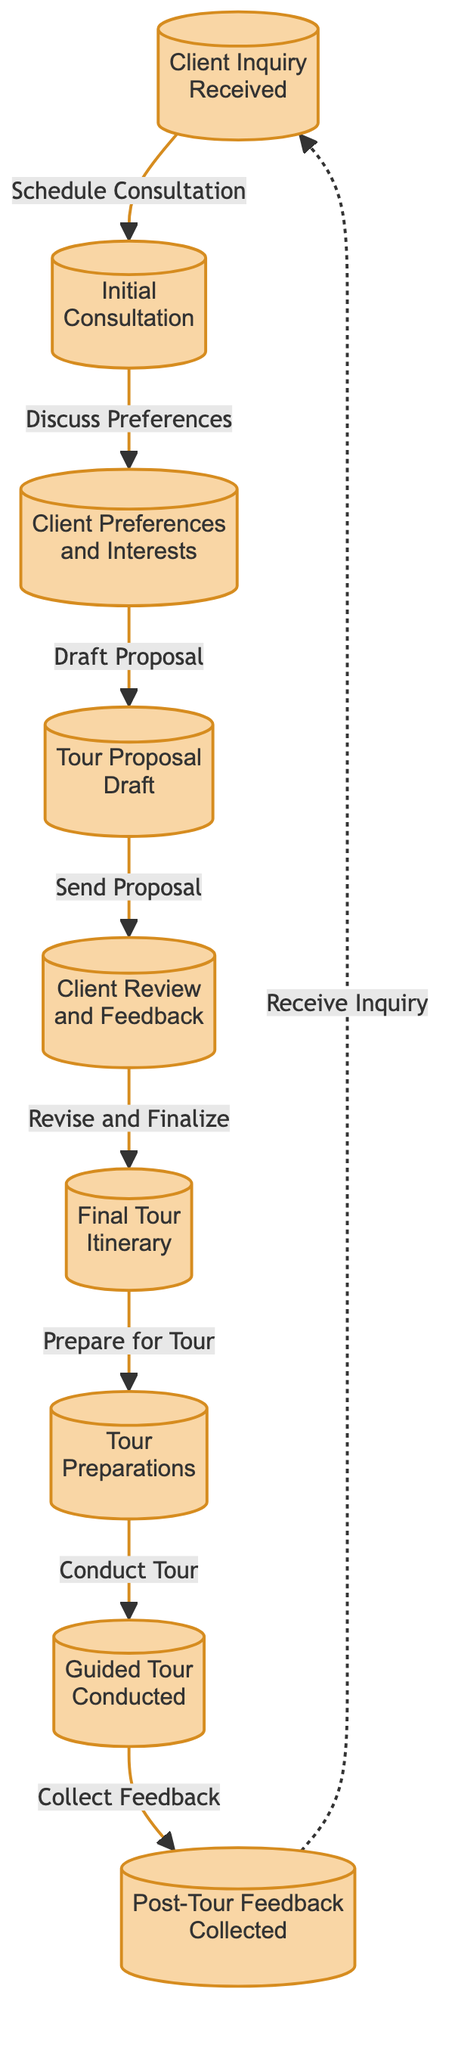What is the first step in the procedure? The first step, as shown in the diagram, is the "Client Inquiry Received" node, indicating that the process begins with receiving an inquiry from the client.
Answer: Client Inquiry Received How many nodes are there in the diagram? By counting the distinct steps represented in the diagram, we identify a total of nine nodes that outline the procedure for organizing a personalized guided tour.
Answer: 9 What is the relationship between "Client Review and Feedback" and "Final Tour Itinerary"? The relationship is that the "Client Review and Feedback" node is directly connected to the "Final Tour Itinerary" node, signifying that client input leads to finalizing the itinerary.
Answer: Revise and Finalize What step follows the "Guided Tour Conducted"? The step that follows "Guided Tour Conducted" is the "Post-Tour Feedback Collected," indicating that after the tour, the focus is on gathering feedback from the clients.
Answer: Post-Tour Feedback Collected Which node is connected to the "Client Inquiry Received"? The "Client Inquiry Received" node is connected back to itself via a dotted line labeled "Receive Inquiry," suggesting a continuous loop of inquiries that can start the process over.
Answer: Receive Inquiry What is the last step in the organizing procedure? The last step in the procedure, as indicated in the diagram, is the "Post-Tour Feedback Collected" node, which concludes the process of organizing the tour.
Answer: Post-Tour Feedback Collected What is the penultimate step before the tour is conducted? The step before the tour is "Tour Preparations," which indicates that preparations must be made just prior to the actual conducting of the tour.
Answer: Tour Preparations What role does "Client Preferences and Interests" play in the flowchart? "Client Preferences and Interests" serves as a crucial step in which the guide discusses and gathers information from the client to help tailor the tour according to their preferences.
Answer: Draft Proposal What type of diagram is illustrated here? This is a flowchart, as it visually represents the sequential steps involved in organizing a personalized guided tour and the relationships between those steps.
Answer: Flowchart 